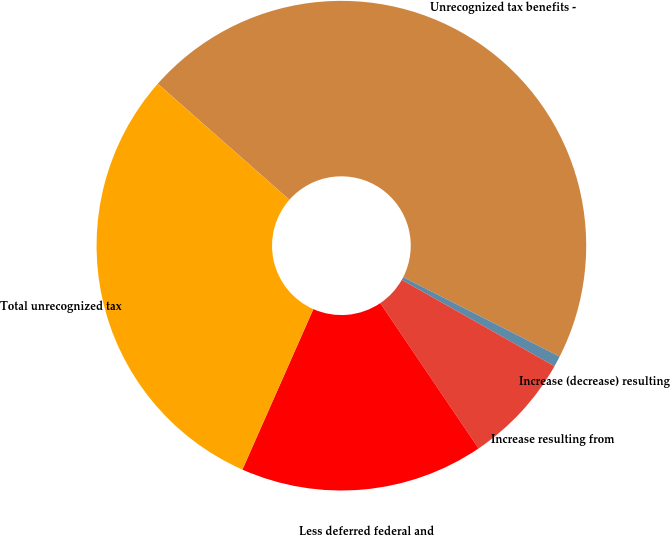<chart> <loc_0><loc_0><loc_500><loc_500><pie_chart><fcel>Unrecognized tax benefits -<fcel>Increase (decrease) resulting<fcel>Increase resulting from<fcel>Less deferred federal and<fcel>Total unrecognized tax<nl><fcel>45.98%<fcel>0.71%<fcel>7.34%<fcel>16.09%<fcel>29.88%<nl></chart> 